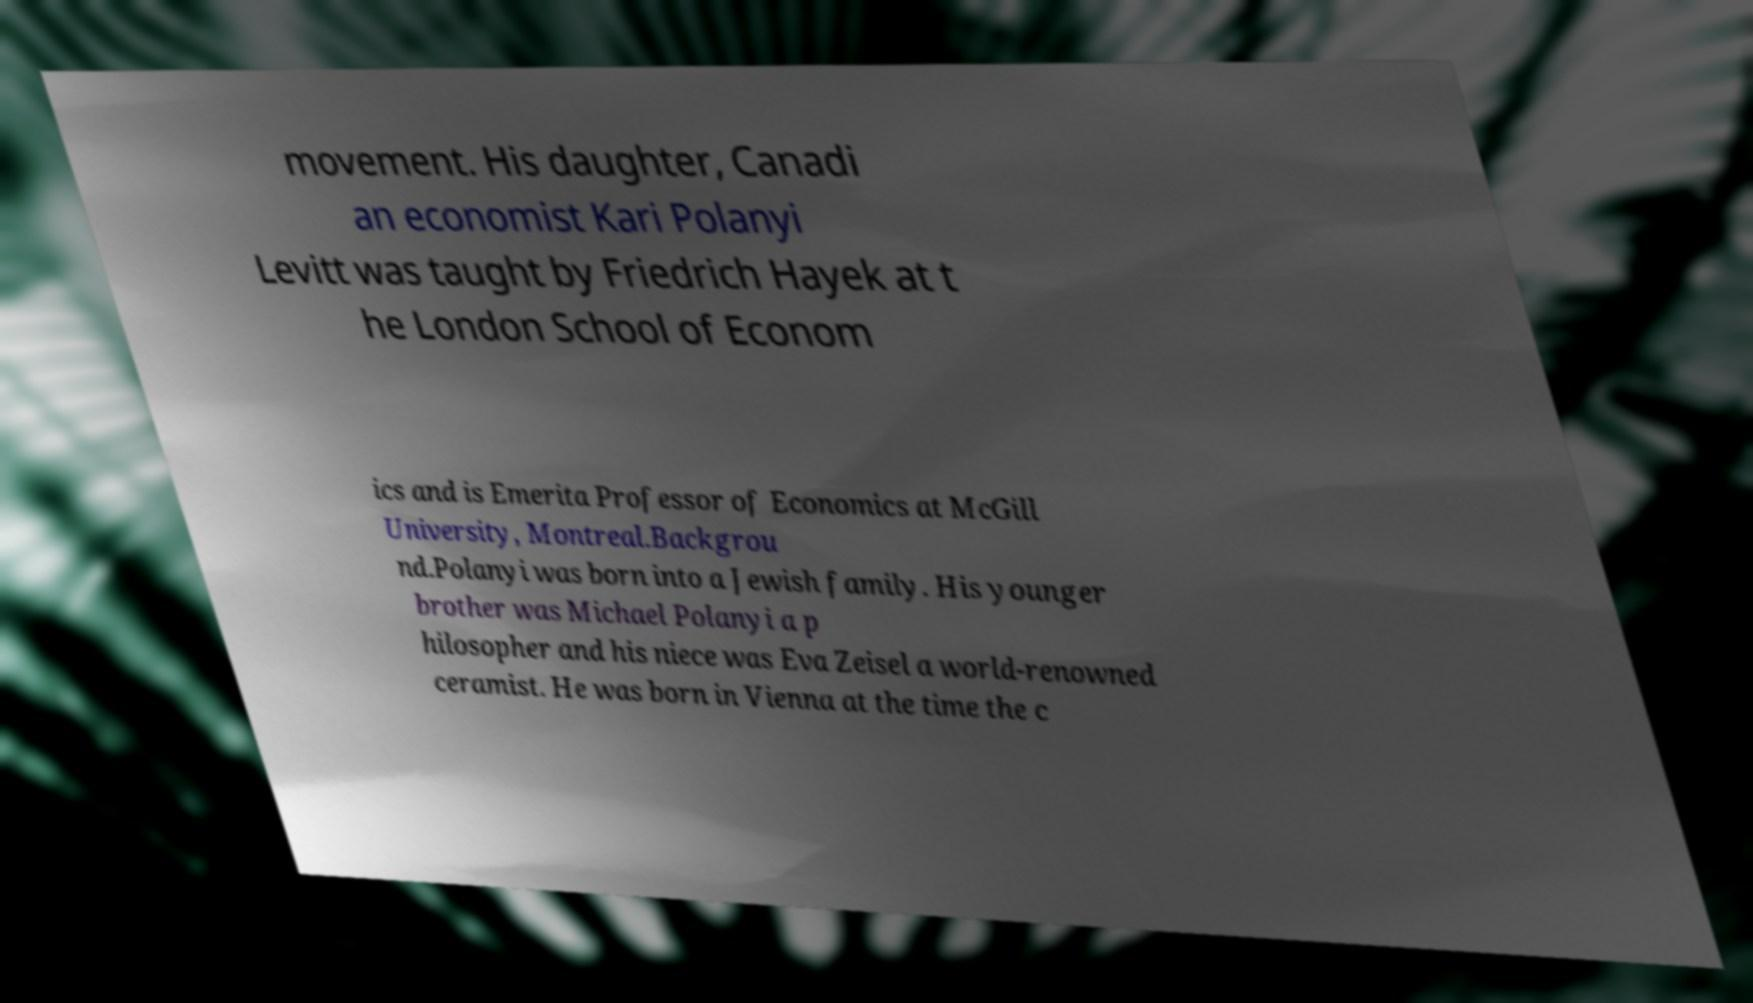Can you accurately transcribe the text from the provided image for me? movement. His daughter, Canadi an economist Kari Polanyi Levitt was taught by Friedrich Hayek at t he London School of Econom ics and is Emerita Professor of Economics at McGill University, Montreal.Backgrou nd.Polanyi was born into a Jewish family. His younger brother was Michael Polanyi a p hilosopher and his niece was Eva Zeisel a world-renowned ceramist. He was born in Vienna at the time the c 